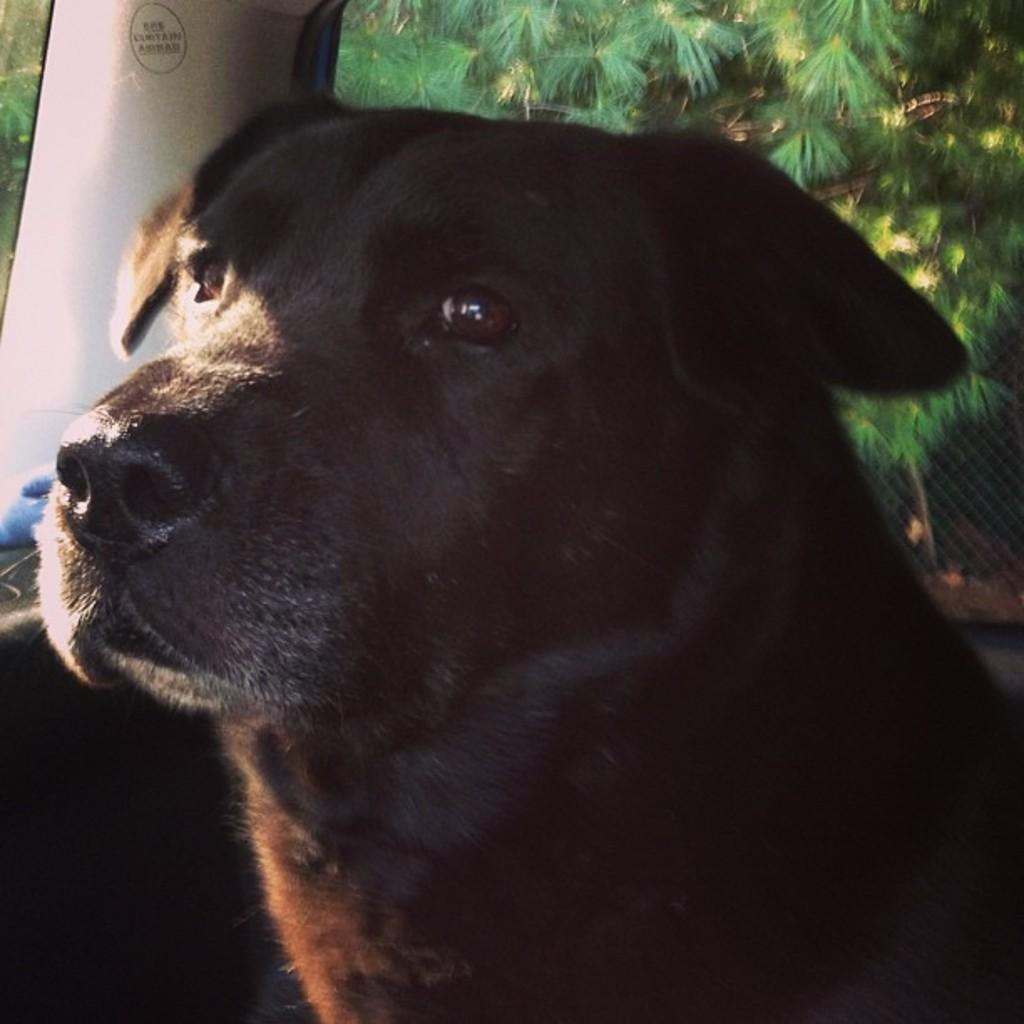What is the main subject in the foreground of the image? There is a dog in the foreground of the image. Where is the dog located in the image? The dog appears to be in a vehicle. What can be seen in the background of the image? There are plants and a net in the background of the image. What advice does the dog give to the plants in the image? There is no indication in the image that the dog is giving advice to the plants, as dogs do not communicate in this manner. 